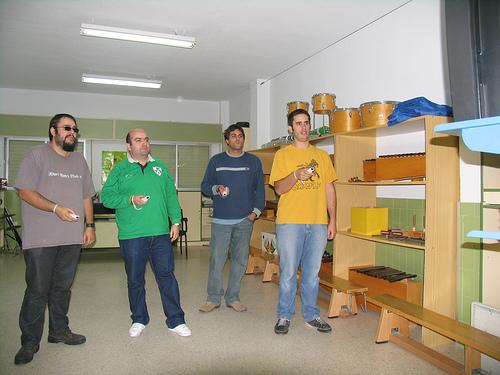Is the door behind the man open or closed?
Quick response, please. Closed. Is this an office party?
Be succinct. No. How many lights are on the ceiling?
Concise answer only. 2. How many people are shown?
Quick response, please. 4. What color is the ceiling?
Be succinct. White. How many people in the picture are wearing the same yellow t-shirt?
Quick response, please. 1. 